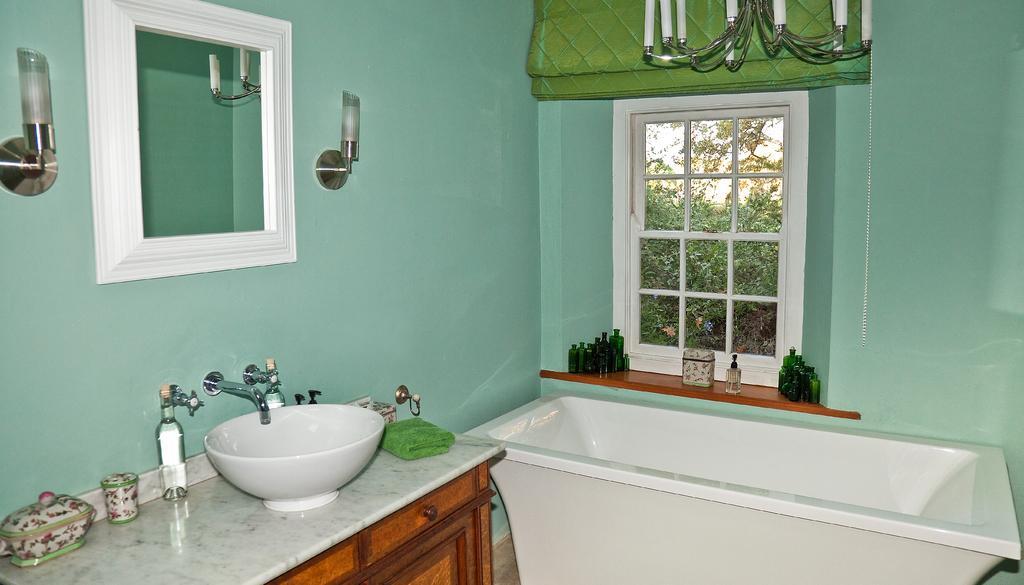In one or two sentences, can you explain what this image depicts? This is an inside view of a room. At the bottom there is a table on which a bottle, box, glass, cloth and a sink are placed and also there is a tap. Beside the table there is a bathtub. On the right side there is a window through which we can see the outside view. In the outside there are many trees. At the top of the window there is a green color cloth and few lights. It seems to be a chandelier. On the left side there is a mirror attached to the wall. On both sides of the mirror there are two lights. Here I can see few bottles beside the window. 